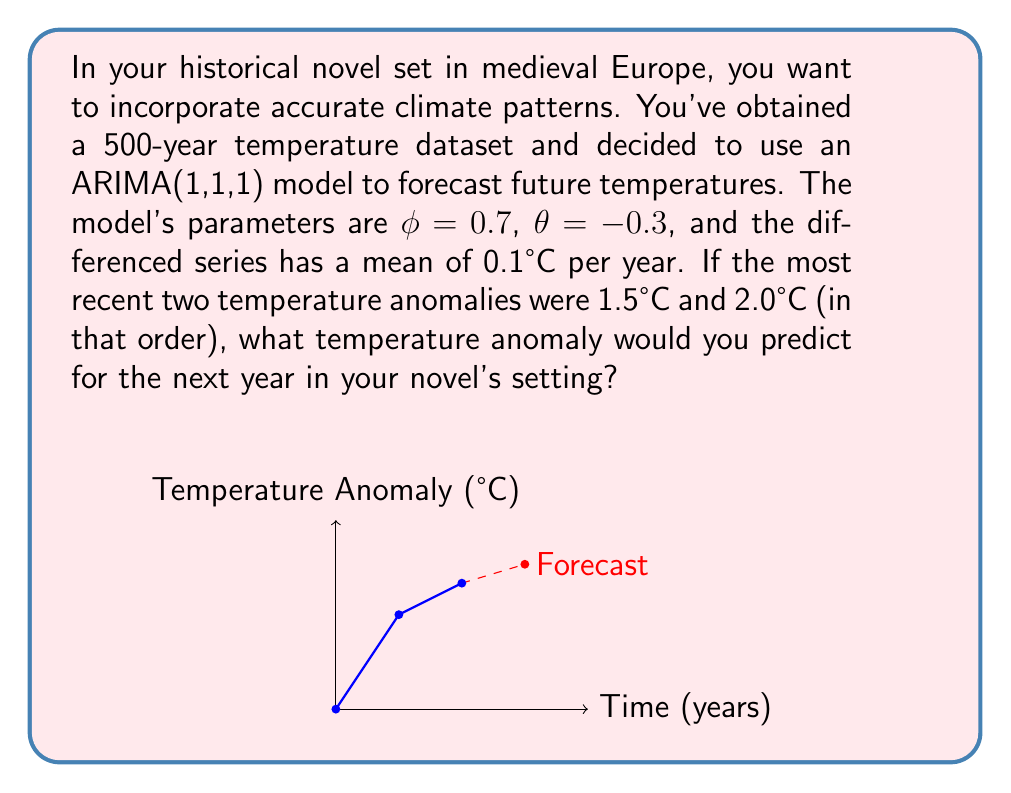What is the answer to this math problem? Let's approach this step-by-step using the ARIMA(1,1,1) model:

1) The general form of an ARIMA(1,1,1) model is:
   $$(1-\phi B)(1-B)y_t = (1+\theta B)\epsilon_t + c$$
   where $B$ is the backshift operator, $c$ is the drift term, and $\epsilon_t$ is white noise.

2) For forecasting, we can rewrite this as:
   $$y_t = y_{t-1} + \phi(y_{t-1} - y_{t-2}) + \theta\epsilon_{t-1} + \epsilon_t + c$$

3) We're given:
   $\phi = 0.7$
   $\theta = -0.3$
   $c = 0.1$ (the mean of the differenced series)
   $y_{t-1} = 2.0$
   $y_{t-2} = 1.5$

4) For one-step-ahead forecasting, we set $\epsilon_t = 0$ (its expected value) and use the most recent known error term for $\epsilon_{t-1}$. We can calculate this as:
   $$\epsilon_{t-1} = (y_{t-1} - y_{t-2}) - [\phi(y_{t-2} - y_{t-3}) + c]$$
   However, we don't have $y_{t-3}$, so we'll approximate $\epsilon_{t-1} = 0$.

5) Now, let's substitute these values into our forecasting equation:
   $$\hat{y}_t = 2.0 + 0.7(2.0 - 1.5) + (-0.3 \cdot 0) + 0 + 0.1$$

6) Simplifying:
   $$\hat{y}_t = 2.0 + 0.7(0.5) + 0.1 = 2.0 + 0.35 + 0.1 = 2.45$$

Therefore, the predicted temperature anomaly for the next year in your novel's setting would be 2.45°C.
Answer: 2.45°C 